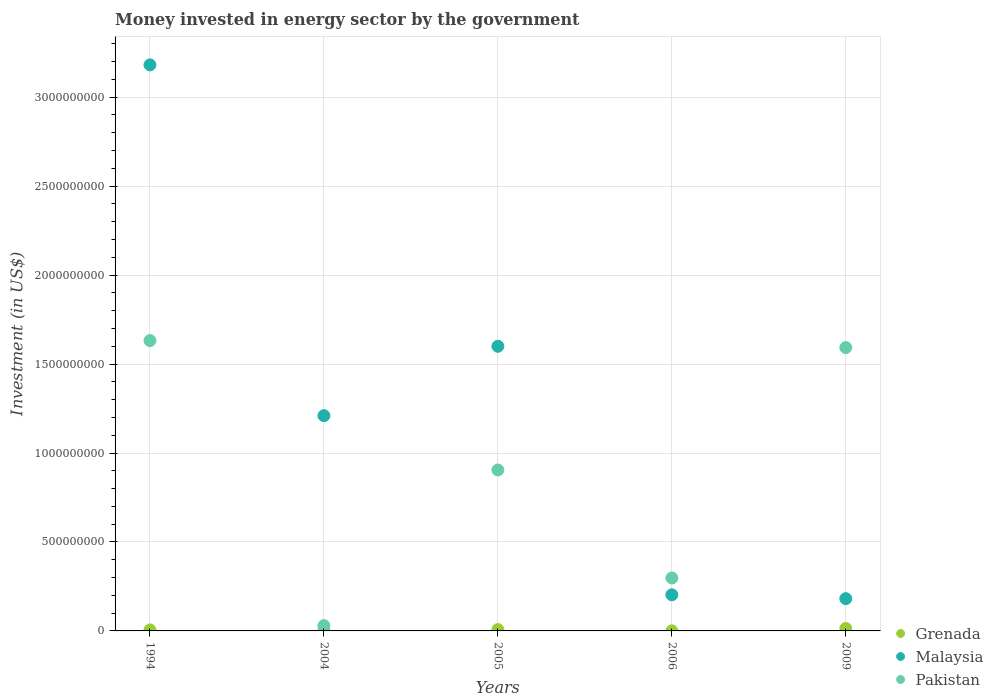What is the money spent in energy sector in Pakistan in 2004?
Your answer should be compact. 2.98e+07. Across all years, what is the maximum money spent in energy sector in Malaysia?
Provide a succinct answer. 3.18e+09. Across all years, what is the minimum money spent in energy sector in Pakistan?
Keep it short and to the point. 2.98e+07. In which year was the money spent in energy sector in Malaysia maximum?
Offer a very short reply. 1994. What is the total money spent in energy sector in Malaysia in the graph?
Provide a succinct answer. 6.38e+09. What is the difference between the money spent in energy sector in Malaysia in 2004 and that in 2005?
Offer a very short reply. -3.90e+08. What is the difference between the money spent in energy sector in Pakistan in 2006 and the money spent in energy sector in Grenada in 2004?
Make the answer very short. 2.96e+08. What is the average money spent in energy sector in Grenada per year?
Ensure brevity in your answer.  5.74e+06. In the year 2009, what is the difference between the money spent in energy sector in Malaysia and money spent in energy sector in Pakistan?
Provide a succinct answer. -1.41e+09. In how many years, is the money spent in energy sector in Malaysia greater than 1700000000 US$?
Offer a terse response. 1. What is the ratio of the money spent in energy sector in Grenada in 1994 to that in 2006?
Make the answer very short. 11.2. Is the money spent in energy sector in Pakistan in 2004 less than that in 2005?
Provide a succinct answer. Yes. Is the difference between the money spent in energy sector in Malaysia in 1994 and 2009 greater than the difference between the money spent in energy sector in Pakistan in 1994 and 2009?
Offer a very short reply. Yes. What is the difference between the highest and the second highest money spent in energy sector in Malaysia?
Ensure brevity in your answer.  1.58e+09. What is the difference between the highest and the lowest money spent in energy sector in Pakistan?
Keep it short and to the point. 1.60e+09. In how many years, is the money spent in energy sector in Malaysia greater than the average money spent in energy sector in Malaysia taken over all years?
Offer a terse response. 2. Is it the case that in every year, the sum of the money spent in energy sector in Malaysia and money spent in energy sector in Pakistan  is greater than the money spent in energy sector in Grenada?
Provide a succinct answer. Yes. Does the money spent in energy sector in Pakistan monotonically increase over the years?
Offer a terse response. No. Is the money spent in energy sector in Grenada strictly greater than the money spent in energy sector in Malaysia over the years?
Your response must be concise. No. Is the money spent in energy sector in Pakistan strictly less than the money spent in energy sector in Grenada over the years?
Your response must be concise. No. How many years are there in the graph?
Your answer should be compact. 5. Does the graph contain grids?
Make the answer very short. Yes. How many legend labels are there?
Your response must be concise. 3. How are the legend labels stacked?
Make the answer very short. Vertical. What is the title of the graph?
Give a very brief answer. Money invested in energy sector by the government. Does "Morocco" appear as one of the legend labels in the graph?
Offer a terse response. No. What is the label or title of the X-axis?
Provide a short and direct response. Years. What is the label or title of the Y-axis?
Your response must be concise. Investment (in US$). What is the Investment (in US$) of Grenada in 1994?
Provide a short and direct response. 5.60e+06. What is the Investment (in US$) of Malaysia in 1994?
Offer a very short reply. 3.18e+09. What is the Investment (in US$) of Pakistan in 1994?
Your response must be concise. 1.63e+09. What is the Investment (in US$) in Grenada in 2004?
Ensure brevity in your answer.  1.50e+06. What is the Investment (in US$) in Malaysia in 2004?
Provide a succinct answer. 1.21e+09. What is the Investment (in US$) of Pakistan in 2004?
Keep it short and to the point. 2.98e+07. What is the Investment (in US$) in Grenada in 2005?
Your answer should be very brief. 7.50e+06. What is the Investment (in US$) of Malaysia in 2005?
Make the answer very short. 1.60e+09. What is the Investment (in US$) in Pakistan in 2005?
Your answer should be very brief. 9.05e+08. What is the Investment (in US$) of Malaysia in 2006?
Make the answer very short. 2.03e+08. What is the Investment (in US$) in Pakistan in 2006?
Offer a terse response. 2.98e+08. What is the Investment (in US$) of Grenada in 2009?
Make the answer very short. 1.36e+07. What is the Investment (in US$) of Malaysia in 2009?
Offer a very short reply. 1.82e+08. What is the Investment (in US$) of Pakistan in 2009?
Offer a terse response. 1.59e+09. Across all years, what is the maximum Investment (in US$) in Grenada?
Ensure brevity in your answer.  1.36e+07. Across all years, what is the maximum Investment (in US$) in Malaysia?
Give a very brief answer. 3.18e+09. Across all years, what is the maximum Investment (in US$) in Pakistan?
Keep it short and to the point. 1.63e+09. Across all years, what is the minimum Investment (in US$) of Grenada?
Offer a terse response. 5.00e+05. Across all years, what is the minimum Investment (in US$) in Malaysia?
Give a very brief answer. 1.82e+08. Across all years, what is the minimum Investment (in US$) of Pakistan?
Your answer should be compact. 2.98e+07. What is the total Investment (in US$) of Grenada in the graph?
Keep it short and to the point. 2.87e+07. What is the total Investment (in US$) in Malaysia in the graph?
Give a very brief answer. 6.38e+09. What is the total Investment (in US$) of Pakistan in the graph?
Offer a very short reply. 4.46e+09. What is the difference between the Investment (in US$) in Grenada in 1994 and that in 2004?
Your answer should be very brief. 4.10e+06. What is the difference between the Investment (in US$) in Malaysia in 1994 and that in 2004?
Keep it short and to the point. 1.97e+09. What is the difference between the Investment (in US$) in Pakistan in 1994 and that in 2004?
Give a very brief answer. 1.60e+09. What is the difference between the Investment (in US$) of Grenada in 1994 and that in 2005?
Your answer should be compact. -1.90e+06. What is the difference between the Investment (in US$) of Malaysia in 1994 and that in 2005?
Offer a very short reply. 1.58e+09. What is the difference between the Investment (in US$) in Pakistan in 1994 and that in 2005?
Keep it short and to the point. 7.27e+08. What is the difference between the Investment (in US$) of Grenada in 1994 and that in 2006?
Give a very brief answer. 5.10e+06. What is the difference between the Investment (in US$) of Malaysia in 1994 and that in 2006?
Offer a very short reply. 2.98e+09. What is the difference between the Investment (in US$) in Pakistan in 1994 and that in 2006?
Your answer should be compact. 1.33e+09. What is the difference between the Investment (in US$) in Grenada in 1994 and that in 2009?
Provide a succinct answer. -8.00e+06. What is the difference between the Investment (in US$) of Malaysia in 1994 and that in 2009?
Provide a short and direct response. 3.00e+09. What is the difference between the Investment (in US$) of Pakistan in 1994 and that in 2009?
Keep it short and to the point. 3.92e+07. What is the difference between the Investment (in US$) in Grenada in 2004 and that in 2005?
Offer a very short reply. -6.00e+06. What is the difference between the Investment (in US$) in Malaysia in 2004 and that in 2005?
Your response must be concise. -3.90e+08. What is the difference between the Investment (in US$) of Pakistan in 2004 and that in 2005?
Provide a succinct answer. -8.75e+08. What is the difference between the Investment (in US$) of Grenada in 2004 and that in 2006?
Make the answer very short. 1.00e+06. What is the difference between the Investment (in US$) in Malaysia in 2004 and that in 2006?
Offer a very short reply. 1.01e+09. What is the difference between the Investment (in US$) of Pakistan in 2004 and that in 2006?
Keep it short and to the point. -2.68e+08. What is the difference between the Investment (in US$) in Grenada in 2004 and that in 2009?
Keep it short and to the point. -1.21e+07. What is the difference between the Investment (in US$) of Malaysia in 2004 and that in 2009?
Your response must be concise. 1.03e+09. What is the difference between the Investment (in US$) of Pakistan in 2004 and that in 2009?
Keep it short and to the point. -1.56e+09. What is the difference between the Investment (in US$) of Malaysia in 2005 and that in 2006?
Offer a terse response. 1.40e+09. What is the difference between the Investment (in US$) in Pakistan in 2005 and that in 2006?
Provide a short and direct response. 6.07e+08. What is the difference between the Investment (in US$) of Grenada in 2005 and that in 2009?
Keep it short and to the point. -6.10e+06. What is the difference between the Investment (in US$) in Malaysia in 2005 and that in 2009?
Make the answer very short. 1.42e+09. What is the difference between the Investment (in US$) of Pakistan in 2005 and that in 2009?
Your response must be concise. -6.88e+08. What is the difference between the Investment (in US$) of Grenada in 2006 and that in 2009?
Your answer should be compact. -1.31e+07. What is the difference between the Investment (in US$) in Malaysia in 2006 and that in 2009?
Make the answer very short. 2.15e+07. What is the difference between the Investment (in US$) of Pakistan in 2006 and that in 2009?
Make the answer very short. -1.30e+09. What is the difference between the Investment (in US$) in Grenada in 1994 and the Investment (in US$) in Malaysia in 2004?
Ensure brevity in your answer.  -1.20e+09. What is the difference between the Investment (in US$) of Grenada in 1994 and the Investment (in US$) of Pakistan in 2004?
Your response must be concise. -2.42e+07. What is the difference between the Investment (in US$) in Malaysia in 1994 and the Investment (in US$) in Pakistan in 2004?
Your answer should be very brief. 3.15e+09. What is the difference between the Investment (in US$) in Grenada in 1994 and the Investment (in US$) in Malaysia in 2005?
Give a very brief answer. -1.59e+09. What is the difference between the Investment (in US$) in Grenada in 1994 and the Investment (in US$) in Pakistan in 2005?
Give a very brief answer. -8.99e+08. What is the difference between the Investment (in US$) of Malaysia in 1994 and the Investment (in US$) of Pakistan in 2005?
Offer a very short reply. 2.28e+09. What is the difference between the Investment (in US$) in Grenada in 1994 and the Investment (in US$) in Malaysia in 2006?
Give a very brief answer. -1.97e+08. What is the difference between the Investment (in US$) in Grenada in 1994 and the Investment (in US$) in Pakistan in 2006?
Provide a short and direct response. -2.92e+08. What is the difference between the Investment (in US$) of Malaysia in 1994 and the Investment (in US$) of Pakistan in 2006?
Ensure brevity in your answer.  2.88e+09. What is the difference between the Investment (in US$) in Grenada in 1994 and the Investment (in US$) in Malaysia in 2009?
Ensure brevity in your answer.  -1.76e+08. What is the difference between the Investment (in US$) of Grenada in 1994 and the Investment (in US$) of Pakistan in 2009?
Make the answer very short. -1.59e+09. What is the difference between the Investment (in US$) of Malaysia in 1994 and the Investment (in US$) of Pakistan in 2009?
Your answer should be very brief. 1.59e+09. What is the difference between the Investment (in US$) in Grenada in 2004 and the Investment (in US$) in Malaysia in 2005?
Make the answer very short. -1.60e+09. What is the difference between the Investment (in US$) of Grenada in 2004 and the Investment (in US$) of Pakistan in 2005?
Offer a terse response. -9.03e+08. What is the difference between the Investment (in US$) of Malaysia in 2004 and the Investment (in US$) of Pakistan in 2005?
Make the answer very short. 3.05e+08. What is the difference between the Investment (in US$) in Grenada in 2004 and the Investment (in US$) in Malaysia in 2006?
Make the answer very short. -2.02e+08. What is the difference between the Investment (in US$) of Grenada in 2004 and the Investment (in US$) of Pakistan in 2006?
Offer a very short reply. -2.96e+08. What is the difference between the Investment (in US$) of Malaysia in 2004 and the Investment (in US$) of Pakistan in 2006?
Give a very brief answer. 9.12e+08. What is the difference between the Investment (in US$) in Grenada in 2004 and the Investment (in US$) in Malaysia in 2009?
Your answer should be compact. -1.80e+08. What is the difference between the Investment (in US$) in Grenada in 2004 and the Investment (in US$) in Pakistan in 2009?
Provide a succinct answer. -1.59e+09. What is the difference between the Investment (in US$) in Malaysia in 2004 and the Investment (in US$) in Pakistan in 2009?
Keep it short and to the point. -3.83e+08. What is the difference between the Investment (in US$) of Grenada in 2005 and the Investment (in US$) of Malaysia in 2006?
Your answer should be compact. -1.96e+08. What is the difference between the Investment (in US$) of Grenada in 2005 and the Investment (in US$) of Pakistan in 2006?
Your answer should be very brief. -2.90e+08. What is the difference between the Investment (in US$) in Malaysia in 2005 and the Investment (in US$) in Pakistan in 2006?
Keep it short and to the point. 1.30e+09. What is the difference between the Investment (in US$) in Grenada in 2005 and the Investment (in US$) in Malaysia in 2009?
Provide a succinct answer. -1.74e+08. What is the difference between the Investment (in US$) in Grenada in 2005 and the Investment (in US$) in Pakistan in 2009?
Provide a short and direct response. -1.59e+09. What is the difference between the Investment (in US$) in Malaysia in 2005 and the Investment (in US$) in Pakistan in 2009?
Keep it short and to the point. 7.20e+06. What is the difference between the Investment (in US$) of Grenada in 2006 and the Investment (in US$) of Malaysia in 2009?
Keep it short and to the point. -1.81e+08. What is the difference between the Investment (in US$) in Grenada in 2006 and the Investment (in US$) in Pakistan in 2009?
Provide a short and direct response. -1.59e+09. What is the difference between the Investment (in US$) of Malaysia in 2006 and the Investment (in US$) of Pakistan in 2009?
Your response must be concise. -1.39e+09. What is the average Investment (in US$) of Grenada per year?
Offer a terse response. 5.74e+06. What is the average Investment (in US$) in Malaysia per year?
Give a very brief answer. 1.28e+09. What is the average Investment (in US$) of Pakistan per year?
Your answer should be very brief. 8.91e+08. In the year 1994, what is the difference between the Investment (in US$) of Grenada and Investment (in US$) of Malaysia?
Ensure brevity in your answer.  -3.18e+09. In the year 1994, what is the difference between the Investment (in US$) of Grenada and Investment (in US$) of Pakistan?
Your response must be concise. -1.63e+09. In the year 1994, what is the difference between the Investment (in US$) of Malaysia and Investment (in US$) of Pakistan?
Provide a short and direct response. 1.55e+09. In the year 2004, what is the difference between the Investment (in US$) of Grenada and Investment (in US$) of Malaysia?
Provide a short and direct response. -1.21e+09. In the year 2004, what is the difference between the Investment (in US$) in Grenada and Investment (in US$) in Pakistan?
Provide a short and direct response. -2.83e+07. In the year 2004, what is the difference between the Investment (in US$) in Malaysia and Investment (in US$) in Pakistan?
Offer a terse response. 1.18e+09. In the year 2005, what is the difference between the Investment (in US$) of Grenada and Investment (in US$) of Malaysia?
Your response must be concise. -1.59e+09. In the year 2005, what is the difference between the Investment (in US$) of Grenada and Investment (in US$) of Pakistan?
Your answer should be compact. -8.97e+08. In the year 2005, what is the difference between the Investment (in US$) in Malaysia and Investment (in US$) in Pakistan?
Ensure brevity in your answer.  6.95e+08. In the year 2006, what is the difference between the Investment (in US$) in Grenada and Investment (in US$) in Malaysia?
Provide a short and direct response. -2.02e+08. In the year 2006, what is the difference between the Investment (in US$) in Grenada and Investment (in US$) in Pakistan?
Ensure brevity in your answer.  -2.97e+08. In the year 2006, what is the difference between the Investment (in US$) in Malaysia and Investment (in US$) in Pakistan?
Give a very brief answer. -9.46e+07. In the year 2009, what is the difference between the Investment (in US$) in Grenada and Investment (in US$) in Malaysia?
Provide a short and direct response. -1.68e+08. In the year 2009, what is the difference between the Investment (in US$) in Grenada and Investment (in US$) in Pakistan?
Keep it short and to the point. -1.58e+09. In the year 2009, what is the difference between the Investment (in US$) of Malaysia and Investment (in US$) of Pakistan?
Offer a very short reply. -1.41e+09. What is the ratio of the Investment (in US$) of Grenada in 1994 to that in 2004?
Your response must be concise. 3.73. What is the ratio of the Investment (in US$) in Malaysia in 1994 to that in 2004?
Your answer should be very brief. 2.63. What is the ratio of the Investment (in US$) of Pakistan in 1994 to that in 2004?
Provide a succinct answer. 54.77. What is the ratio of the Investment (in US$) of Grenada in 1994 to that in 2005?
Give a very brief answer. 0.75. What is the ratio of the Investment (in US$) of Malaysia in 1994 to that in 2005?
Ensure brevity in your answer.  1.99. What is the ratio of the Investment (in US$) in Pakistan in 1994 to that in 2005?
Your answer should be compact. 1.8. What is the ratio of the Investment (in US$) in Grenada in 1994 to that in 2006?
Your answer should be very brief. 11.2. What is the ratio of the Investment (in US$) in Malaysia in 1994 to that in 2006?
Your answer should be compact. 15.67. What is the ratio of the Investment (in US$) in Pakistan in 1994 to that in 2006?
Provide a succinct answer. 5.48. What is the ratio of the Investment (in US$) of Grenada in 1994 to that in 2009?
Ensure brevity in your answer.  0.41. What is the ratio of the Investment (in US$) of Malaysia in 1994 to that in 2009?
Ensure brevity in your answer.  17.53. What is the ratio of the Investment (in US$) in Pakistan in 1994 to that in 2009?
Keep it short and to the point. 1.02. What is the ratio of the Investment (in US$) in Malaysia in 2004 to that in 2005?
Offer a terse response. 0.76. What is the ratio of the Investment (in US$) of Pakistan in 2004 to that in 2005?
Offer a very short reply. 0.03. What is the ratio of the Investment (in US$) of Malaysia in 2004 to that in 2006?
Give a very brief answer. 5.96. What is the ratio of the Investment (in US$) of Pakistan in 2004 to that in 2006?
Offer a terse response. 0.1. What is the ratio of the Investment (in US$) of Grenada in 2004 to that in 2009?
Provide a short and direct response. 0.11. What is the ratio of the Investment (in US$) in Malaysia in 2004 to that in 2009?
Provide a short and direct response. 6.67. What is the ratio of the Investment (in US$) of Pakistan in 2004 to that in 2009?
Your answer should be very brief. 0.02. What is the ratio of the Investment (in US$) of Malaysia in 2005 to that in 2006?
Keep it short and to the point. 7.88. What is the ratio of the Investment (in US$) of Pakistan in 2005 to that in 2006?
Your response must be concise. 3.04. What is the ratio of the Investment (in US$) in Grenada in 2005 to that in 2009?
Keep it short and to the point. 0.55. What is the ratio of the Investment (in US$) in Malaysia in 2005 to that in 2009?
Make the answer very short. 8.82. What is the ratio of the Investment (in US$) of Pakistan in 2005 to that in 2009?
Give a very brief answer. 0.57. What is the ratio of the Investment (in US$) of Grenada in 2006 to that in 2009?
Ensure brevity in your answer.  0.04. What is the ratio of the Investment (in US$) of Malaysia in 2006 to that in 2009?
Make the answer very short. 1.12. What is the ratio of the Investment (in US$) of Pakistan in 2006 to that in 2009?
Make the answer very short. 0.19. What is the difference between the highest and the second highest Investment (in US$) in Grenada?
Offer a terse response. 6.10e+06. What is the difference between the highest and the second highest Investment (in US$) of Malaysia?
Keep it short and to the point. 1.58e+09. What is the difference between the highest and the second highest Investment (in US$) of Pakistan?
Make the answer very short. 3.92e+07. What is the difference between the highest and the lowest Investment (in US$) of Grenada?
Offer a very short reply. 1.31e+07. What is the difference between the highest and the lowest Investment (in US$) in Malaysia?
Your answer should be very brief. 3.00e+09. What is the difference between the highest and the lowest Investment (in US$) of Pakistan?
Ensure brevity in your answer.  1.60e+09. 